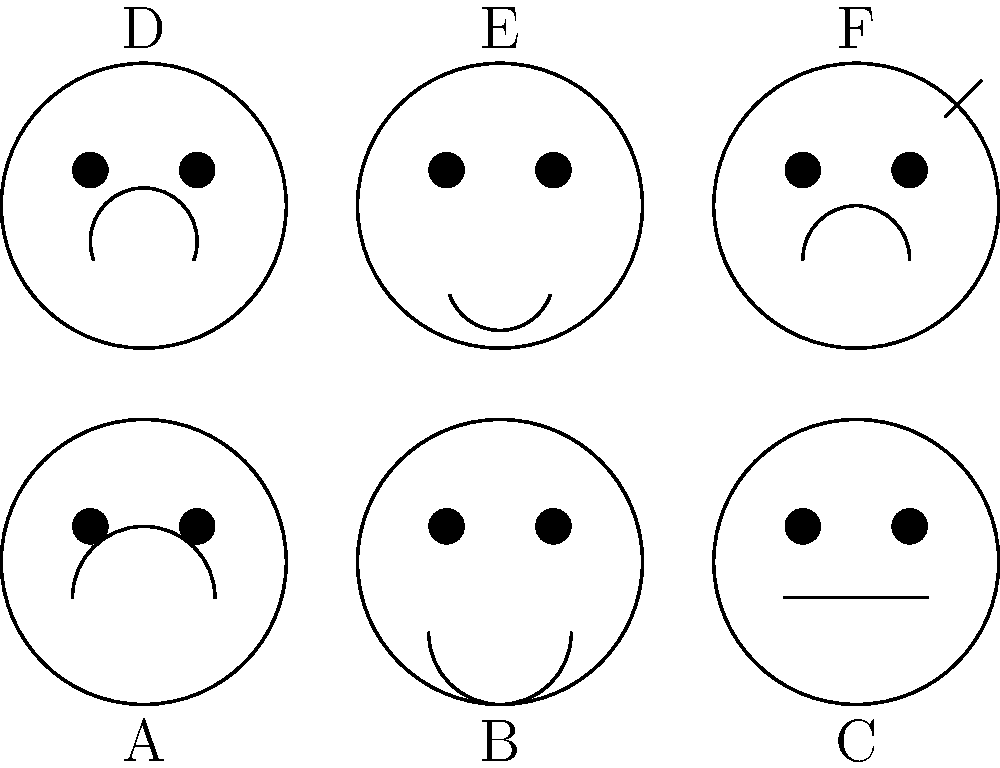In the series of facial expressions shown above, which image would most likely indicate a witness feeling hesitant or uncertain about the information they are providing during an interview? To identify the facial expression that indicates hesitation or uncertainty, we need to analyze each expression:

1. Image A: Shows a smile, indicating happiness or contentment.
2. Image B: Displays a downturned mouth, suggesting sadness or disappointment.
3. Image C: Features a neutral expression, showing no particular emotion.
4. Image D: Exhibits a wide-open mouth, typically associated with surprise or shock.
5. Image E: Shows a furrowed brow and downturned mouth, indicating anger or frustration.
6. Image F: Displays a curved mouth and a raised eyebrow, often associated with confusion or uncertainty.

When a witness feels hesitant or uncertain about the information they're providing, they're likely to display signs of confusion. The facial expression that best represents this state is Image F, which shows a slightly curved mouth (indicating a lack of confidence) and a raised eyebrow (suggesting questioning or doubt).

This expression is commonly seen when someone is trying to recall information but is not entirely sure about the details, which is a frequent occurrence during witness interviews.
Answer: Image F 